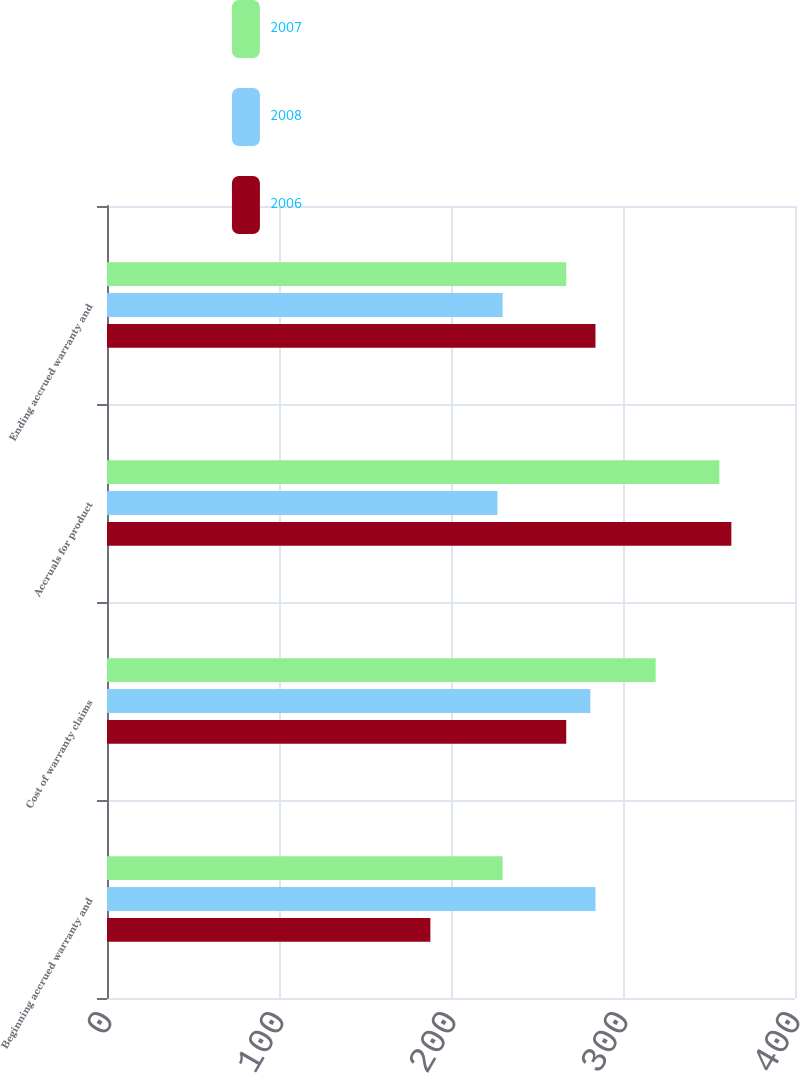Convert chart. <chart><loc_0><loc_0><loc_500><loc_500><stacked_bar_chart><ecel><fcel>Beginning accrued warranty and<fcel>Cost of warranty claims<fcel>Accruals for product<fcel>Ending accrued warranty and<nl><fcel>2007<fcel>230<fcel>319<fcel>356<fcel>267<nl><fcel>2008<fcel>284<fcel>281<fcel>227<fcel>230<nl><fcel>2006<fcel>188<fcel>267<fcel>363<fcel>284<nl></chart> 